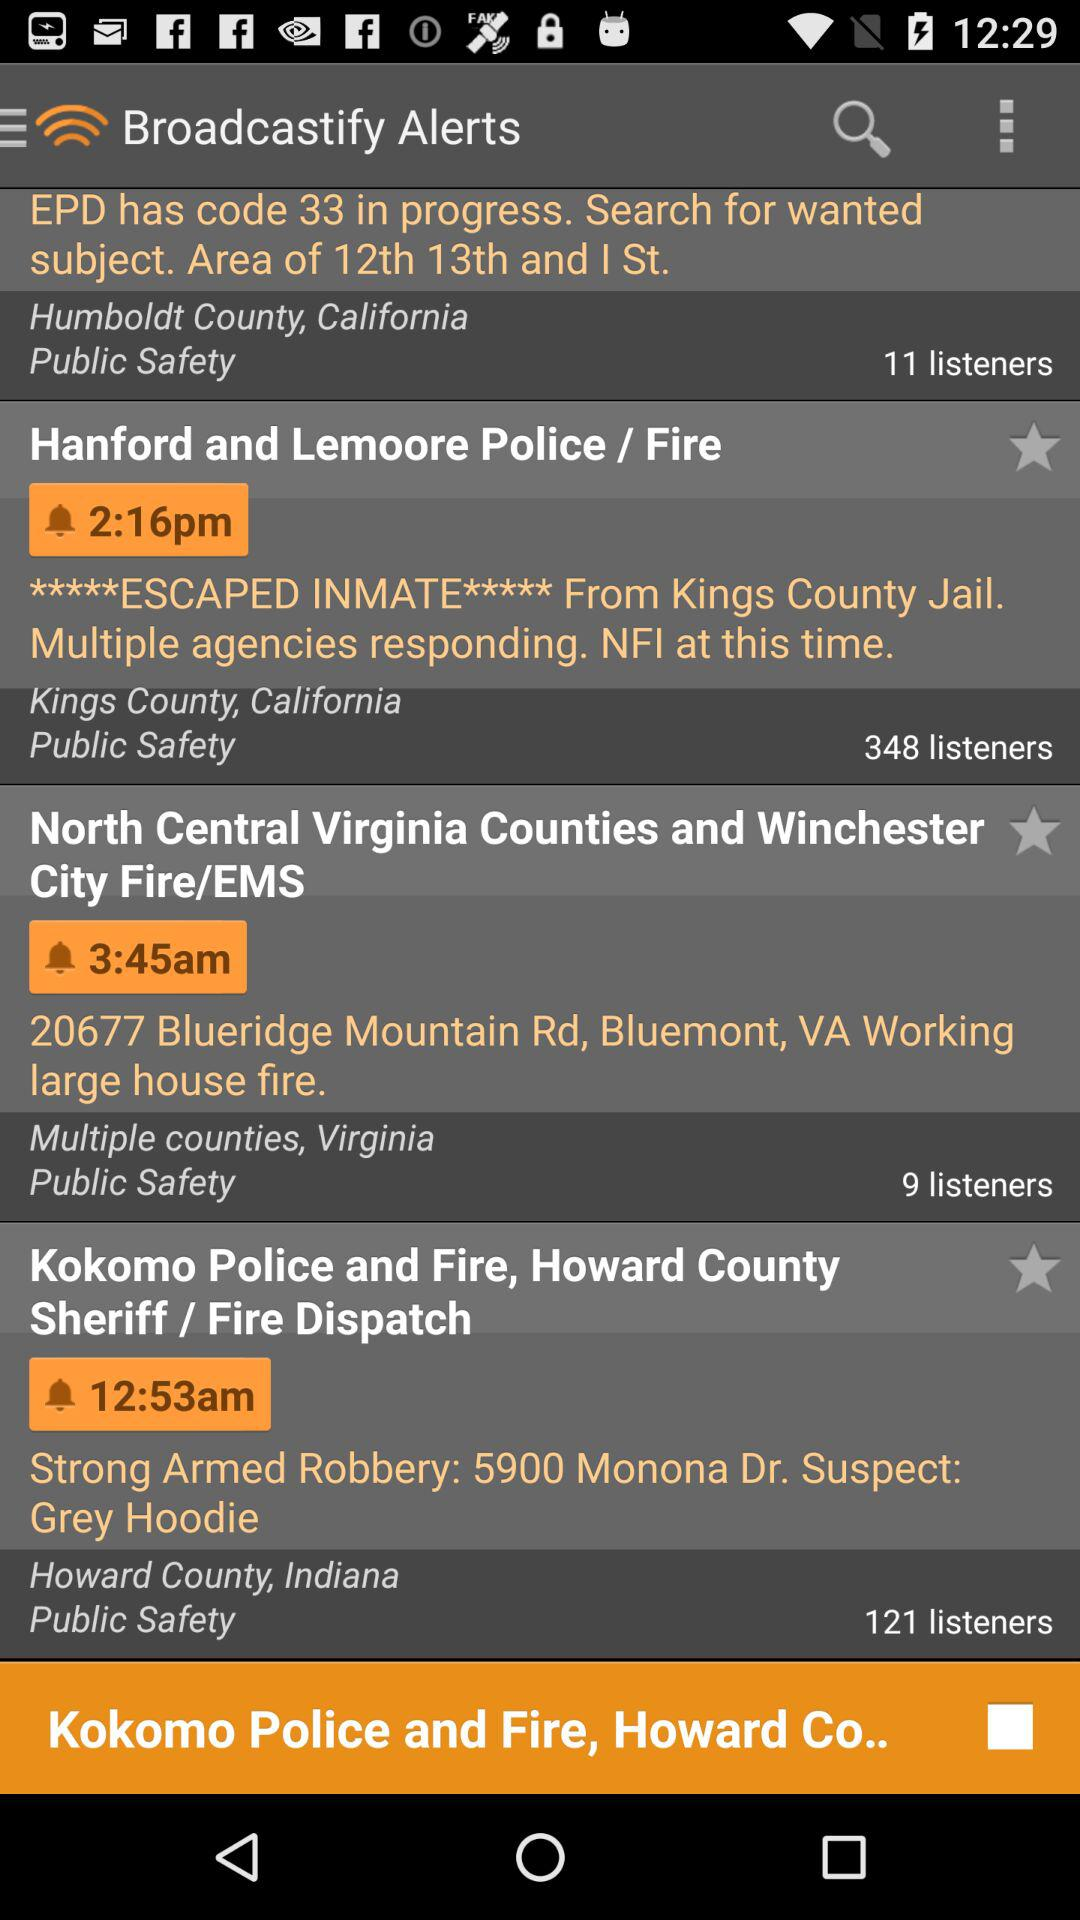How many listeners are there for "North Central Virginia Counties and Winchester City Fire/EMS"? There are 9 listeners. 